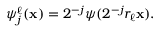Convert formula to latex. <formula><loc_0><loc_0><loc_500><loc_500>\begin{array} { r } { \psi _ { j } ^ { \ell } ( x ) = 2 ^ { - j } \psi ( 2 ^ { - j } r _ { \ell } x ) . } \end{array}</formula> 